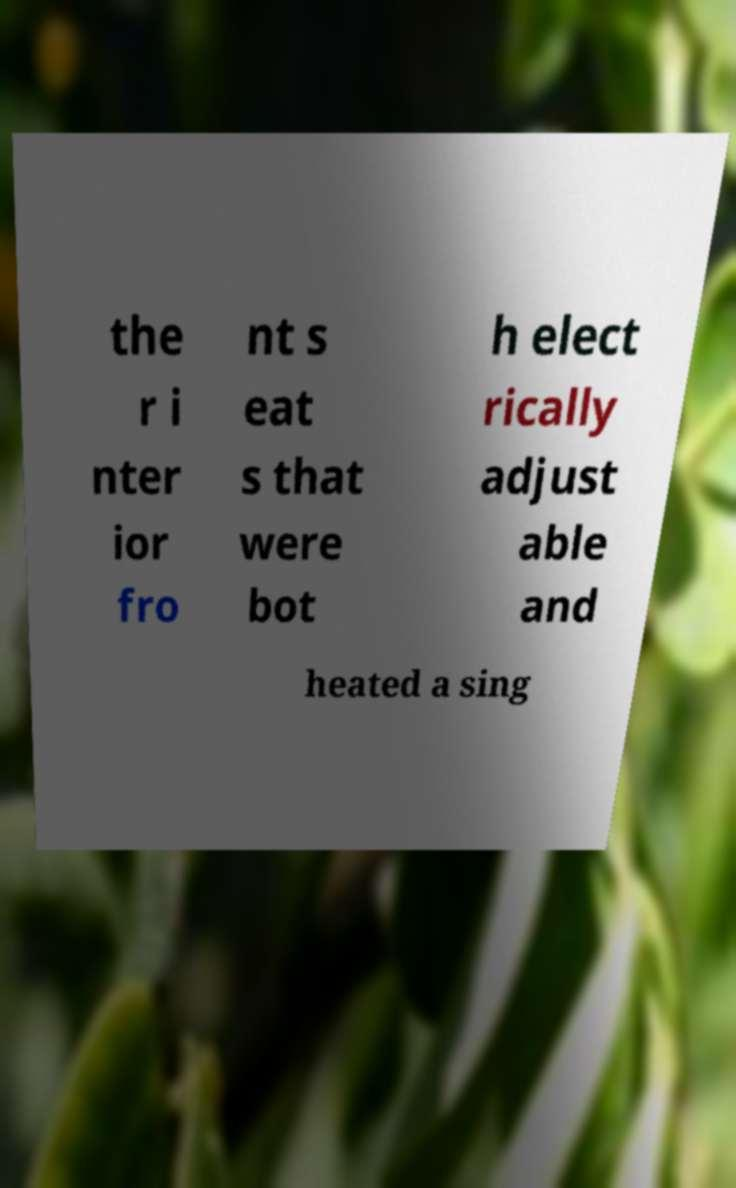What messages or text are displayed in this image? I need them in a readable, typed format. the r i nter ior fro nt s eat s that were bot h elect rically adjust able and heated a sing 